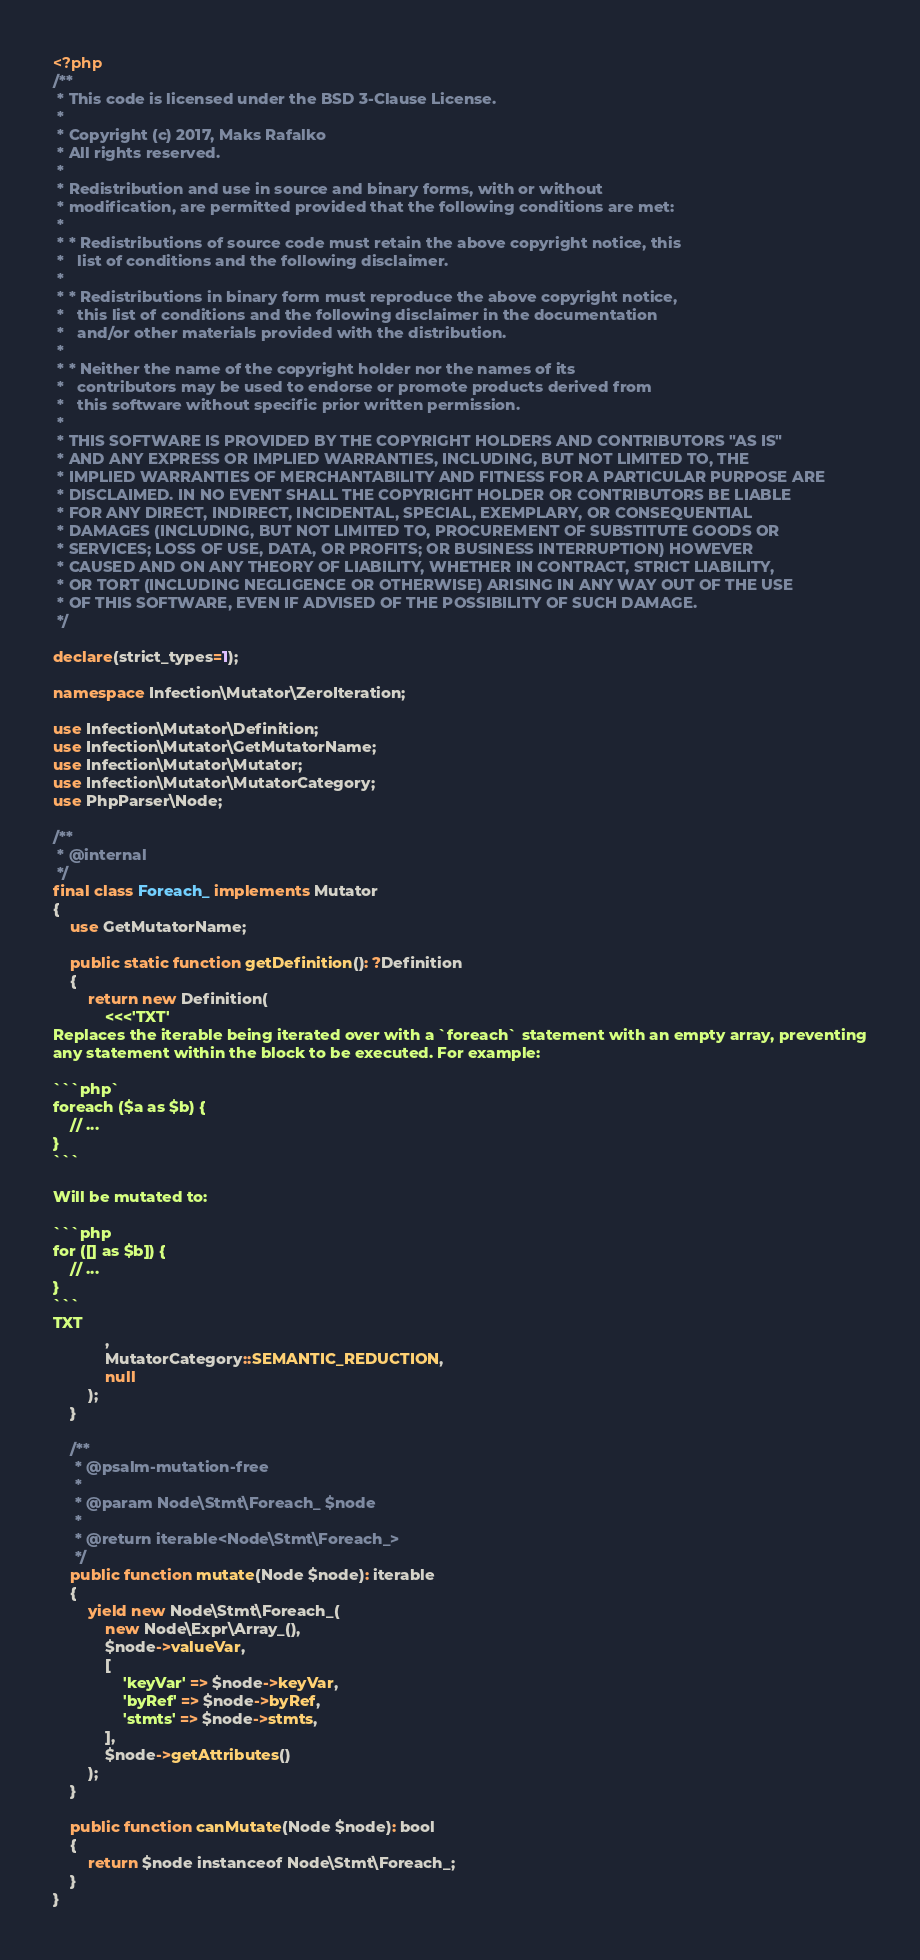Convert code to text. <code><loc_0><loc_0><loc_500><loc_500><_PHP_><?php
/**
 * This code is licensed under the BSD 3-Clause License.
 *
 * Copyright (c) 2017, Maks Rafalko
 * All rights reserved.
 *
 * Redistribution and use in source and binary forms, with or without
 * modification, are permitted provided that the following conditions are met:
 *
 * * Redistributions of source code must retain the above copyright notice, this
 *   list of conditions and the following disclaimer.
 *
 * * Redistributions in binary form must reproduce the above copyright notice,
 *   this list of conditions and the following disclaimer in the documentation
 *   and/or other materials provided with the distribution.
 *
 * * Neither the name of the copyright holder nor the names of its
 *   contributors may be used to endorse or promote products derived from
 *   this software without specific prior written permission.
 *
 * THIS SOFTWARE IS PROVIDED BY THE COPYRIGHT HOLDERS AND CONTRIBUTORS "AS IS"
 * AND ANY EXPRESS OR IMPLIED WARRANTIES, INCLUDING, BUT NOT LIMITED TO, THE
 * IMPLIED WARRANTIES OF MERCHANTABILITY AND FITNESS FOR A PARTICULAR PURPOSE ARE
 * DISCLAIMED. IN NO EVENT SHALL THE COPYRIGHT HOLDER OR CONTRIBUTORS BE LIABLE
 * FOR ANY DIRECT, INDIRECT, INCIDENTAL, SPECIAL, EXEMPLARY, OR CONSEQUENTIAL
 * DAMAGES (INCLUDING, BUT NOT LIMITED TO, PROCUREMENT OF SUBSTITUTE GOODS OR
 * SERVICES; LOSS OF USE, DATA, OR PROFITS; OR BUSINESS INTERRUPTION) HOWEVER
 * CAUSED AND ON ANY THEORY OF LIABILITY, WHETHER IN CONTRACT, STRICT LIABILITY,
 * OR TORT (INCLUDING NEGLIGENCE OR OTHERWISE) ARISING IN ANY WAY OUT OF THE USE
 * OF THIS SOFTWARE, EVEN IF ADVISED OF THE POSSIBILITY OF SUCH DAMAGE.
 */

declare(strict_types=1);

namespace Infection\Mutator\ZeroIteration;

use Infection\Mutator\Definition;
use Infection\Mutator\GetMutatorName;
use Infection\Mutator\Mutator;
use Infection\Mutator\MutatorCategory;
use PhpParser\Node;

/**
 * @internal
 */
final class Foreach_ implements Mutator
{
    use GetMutatorName;

    public static function getDefinition(): ?Definition
    {
        return new Definition(
            <<<'TXT'
Replaces the iterable being iterated over with a `foreach` statement with an empty array, preventing
any statement within the block to be executed. For example:

```php`
foreach ($a as $b) {
    // ...
}
```

Will be mutated to:

```php
for ([] as $b]) {
    // ...
}
```
TXT
            ,
            MutatorCategory::SEMANTIC_REDUCTION,
            null
        );
    }

    /**
     * @psalm-mutation-free
     *
     * @param Node\Stmt\Foreach_ $node
     *
     * @return iterable<Node\Stmt\Foreach_>
     */
    public function mutate(Node $node): iterable
    {
        yield new Node\Stmt\Foreach_(
            new Node\Expr\Array_(),
            $node->valueVar,
            [
                'keyVar' => $node->keyVar,
                'byRef' => $node->byRef,
                'stmts' => $node->stmts,
            ],
            $node->getAttributes()
        );
    }

    public function canMutate(Node $node): bool
    {
        return $node instanceof Node\Stmt\Foreach_;
    }
}
</code> 